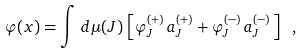Convert formula to latex. <formula><loc_0><loc_0><loc_500><loc_500>\varphi ( x ) = \int \, d \mu ( J ) \, \left [ \varphi ^ { ( + ) } _ { J } \, a ^ { ( + ) } _ { J } + \varphi ^ { ( - ) } _ { J } \, a ^ { ( - ) } _ { J } \, \right ] \ ,</formula> 